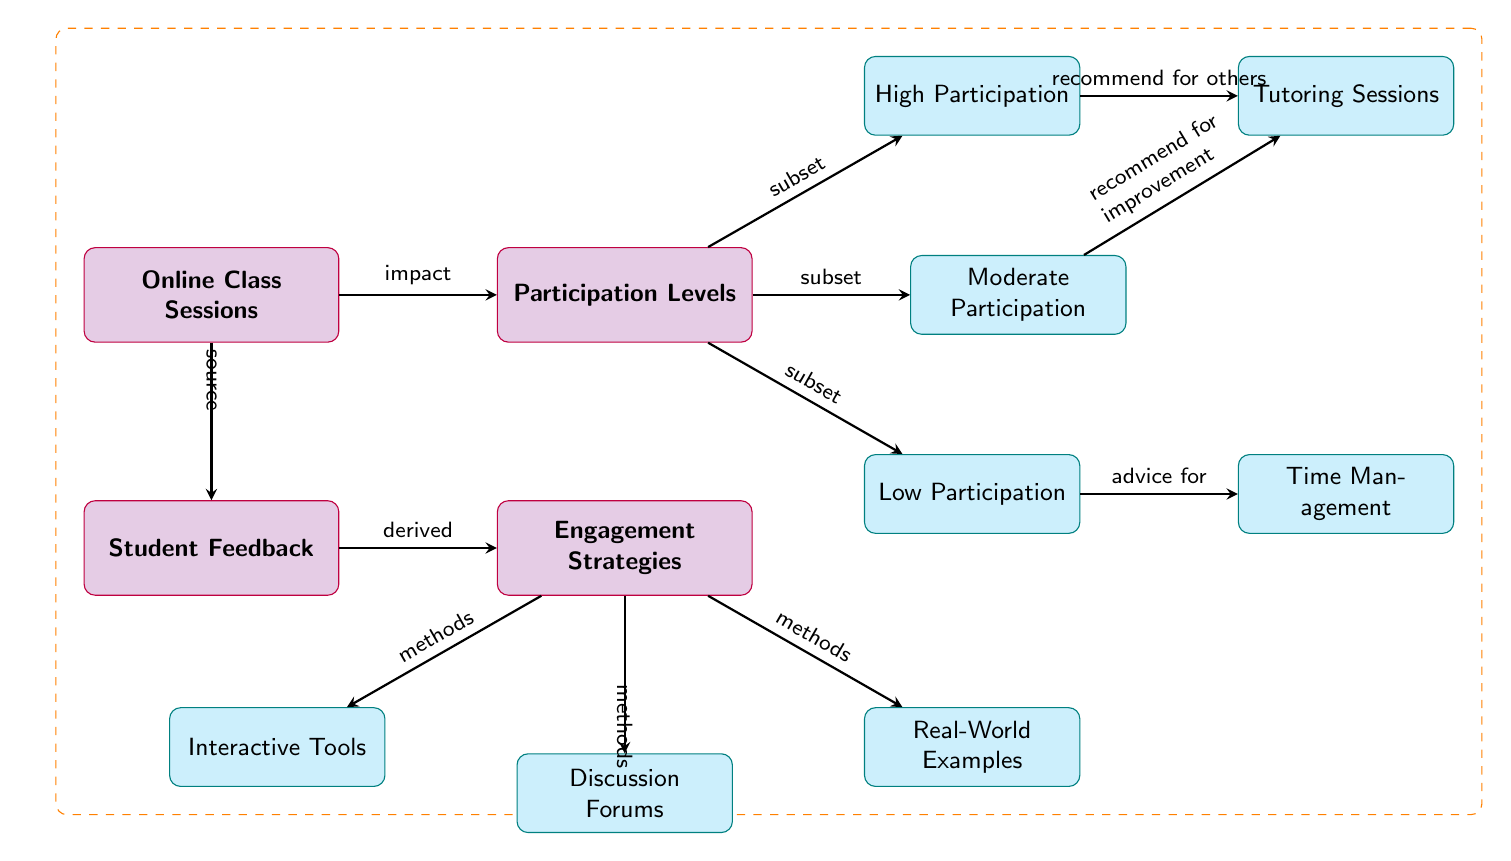What is the main focus of the diagram? The main focus of the diagram is to illustrate "Online Class Sessions" and their impact on "Participation Levels." This is indicated by the main node labeled "Online Class Sessions" at the top left and the corresponding "Participation Levels" node.
Answer: Online Class Sessions How many participation levels are identified in the diagram? The diagram displays three distinct participation levels: "High Participation," "Moderate Participation," and "Low Participation." This can be seen directly from the nodes branching out from "Participation Levels."
Answer: Three Which engagement strategy is connected to the "High Participation" node? The "High Participation" node is connected to "Tutoring Sessions" as a recommendation for others. This relationship is represented by the edge connecting these two nodes in the diagram.
Answer: Tutoring Sessions What method is used for engagement strategies according to the diagram? The diagram lists "Interactive Tools," "Discussion Forums," and "Real-World Examples" as methods related to the engagement strategies, indicated by edges leading from "Engagement Strategies" to these nodes.
Answer: Interactive Tools What advice is given for "Low Participation" students? The diagram indicates that "Advice for Time Management" is the recommendation for students in the "Low Participation" category, as depicted by the edge connecting "Low Participation" to "Time Management."
Answer: Time Management Identify the node that represents student feedback. In the diagram, "Student Feedback" represents the collection of student responses related to online class participation and strategies. It is situated below the "Online Class Sessions" node.
Answer: Student Feedback How does student feedback relate to engagement strategies? The diagram shows that "Student Feedback" is a source for deriving "Engagement Strategies," indicating that feedback informs the methods used to enhance student participation in online classes.
Answer: Derived What type of participation level does "Moderate Participation" recommend for improvement? The diagram illustrates that "Moderate Participation" is connected to "Tutoring Sessions," emphasizing the potential for improvement through these sessions as indicated on the path from the "Moderate Participation" node.
Answer: Tutoring Sessions 